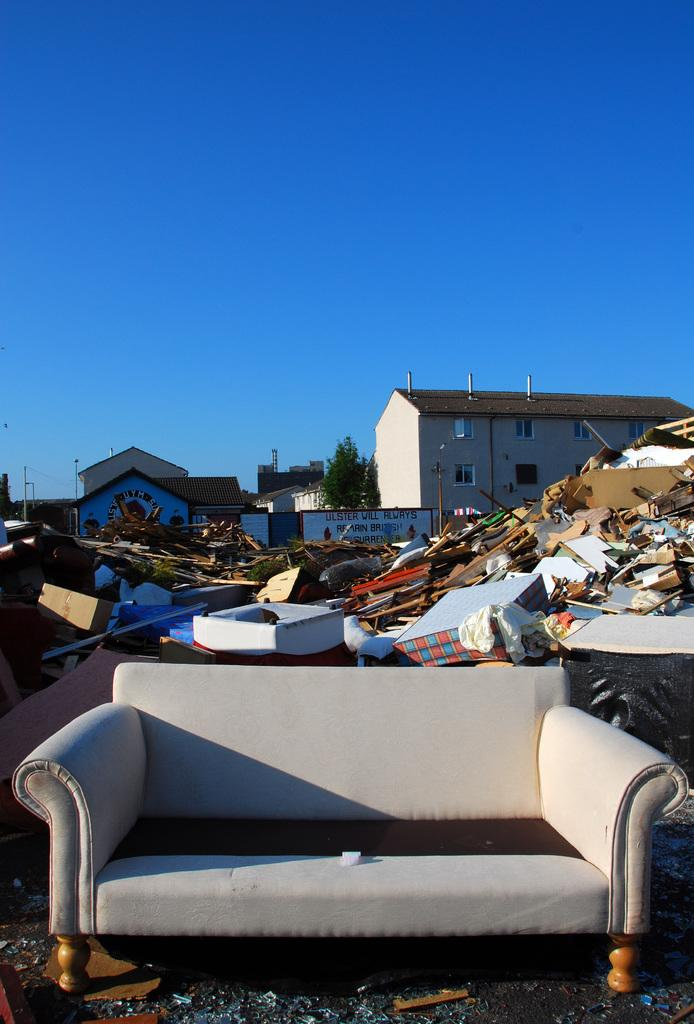What type of furniture is present in the image? There is a sofa in the image. What else can be seen in the image besides the sofa? There is trash in the image. What can be seen in the background of the image? There is a house and a tree in the background of the image, as well as the sky. What type of string can be seen connecting the bike to the aftermath in the image? There is no bike or string present in the image. The image features a sofa, trash, a house, a tree, and the sky in the background. 